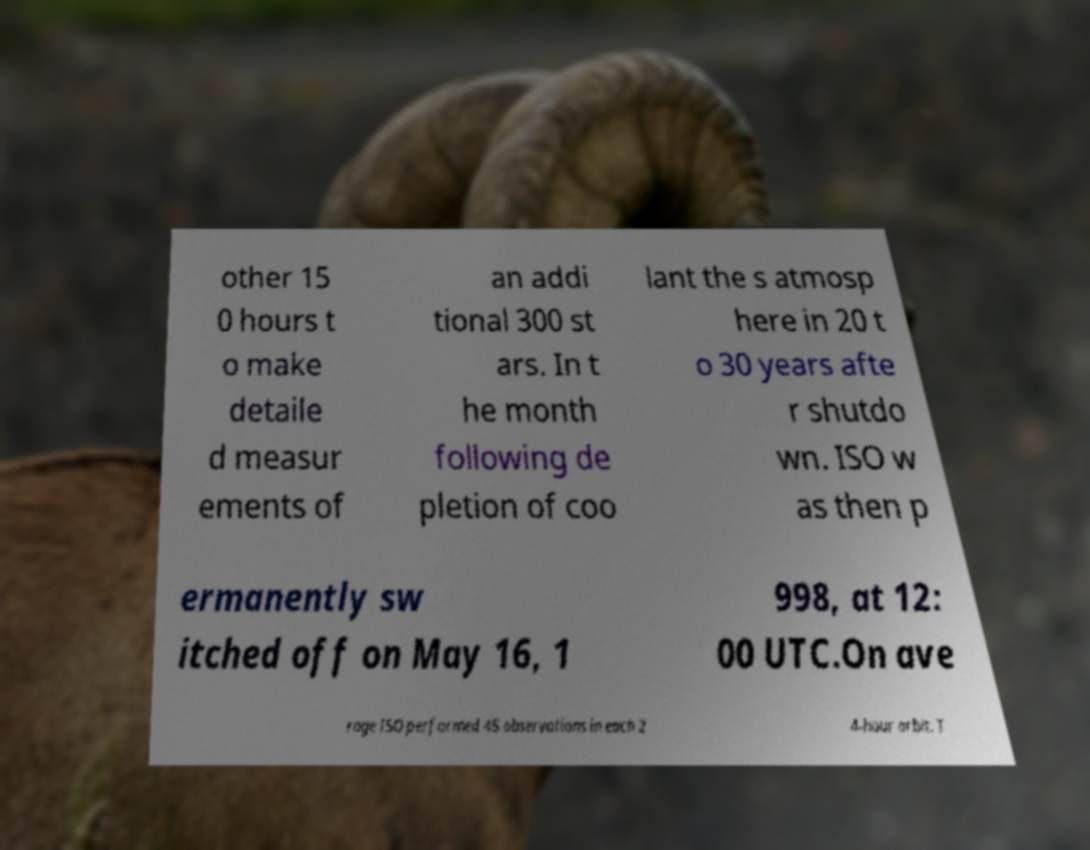What messages or text are displayed in this image? I need them in a readable, typed format. other 15 0 hours t o make detaile d measur ements of an addi tional 300 st ars. In t he month following de pletion of coo lant the s atmosp here in 20 t o 30 years afte r shutdo wn. ISO w as then p ermanently sw itched off on May 16, 1 998, at 12: 00 UTC.On ave rage ISO performed 45 observations in each 2 4-hour orbit. T 